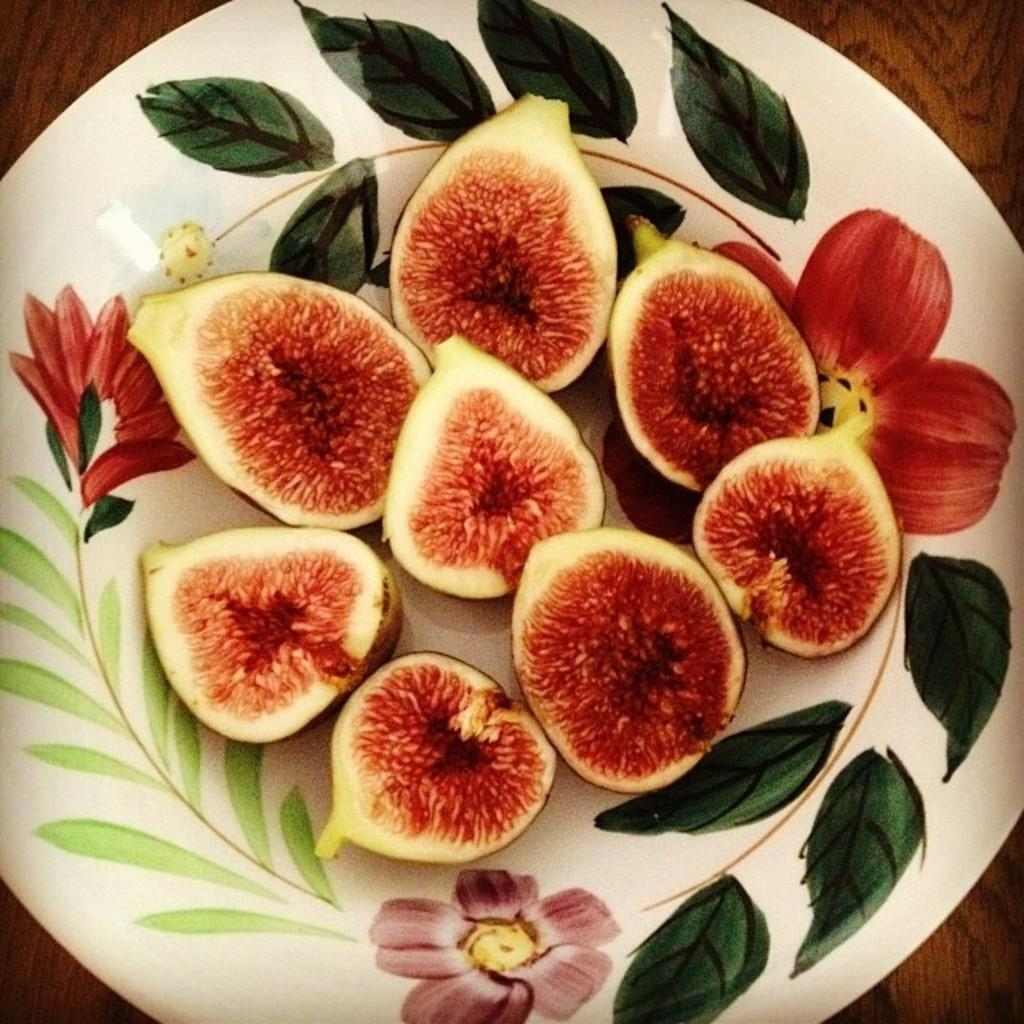What type of food is visible in the image? There are pieces of figs in the image. How are the figs arranged in the image? The figs are in a plate. Where is the plate with figs located? The plate is placed on a table. What type of playground equipment can be seen in the image? There is no playground equipment present in the image; it features pieces of figs in a plate on a table. 